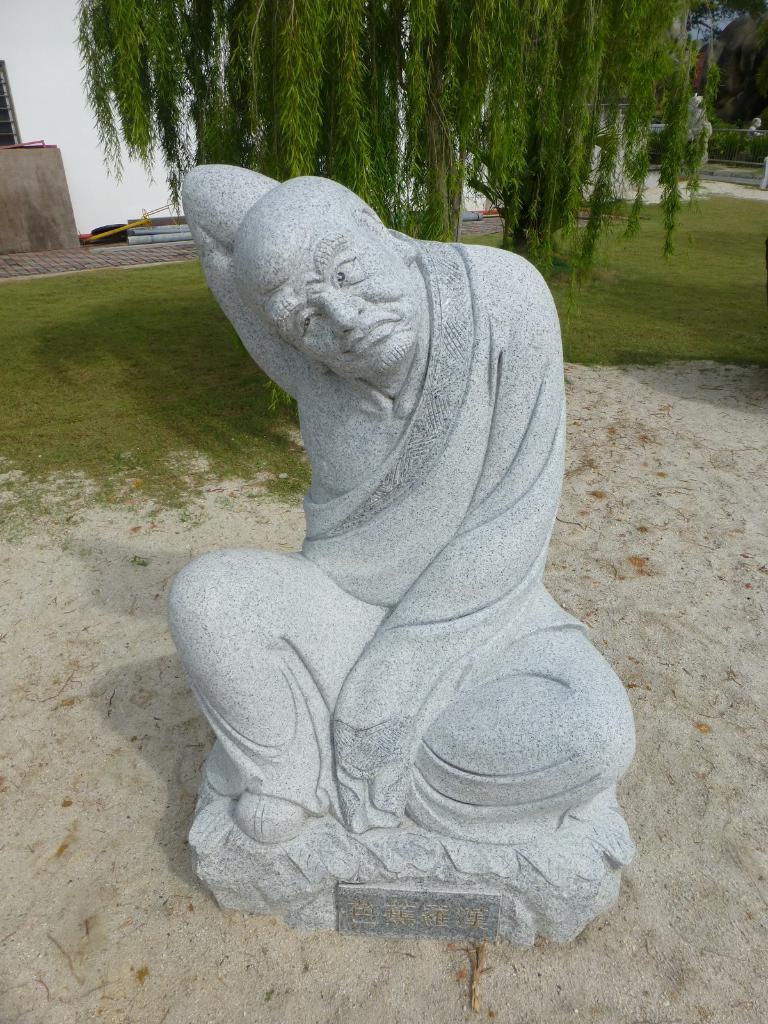Can you describe this image briefly? In the center of the image we can see a sculpture. In the background there is a tree and a building. 